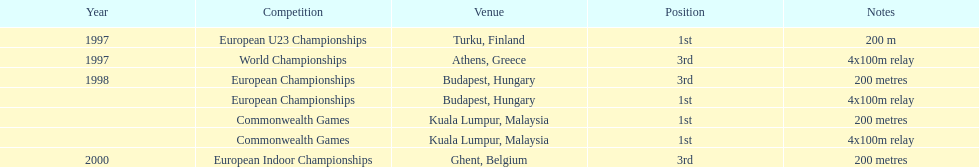What was the exclusive event achieved in belgium? European Indoor Championships. 